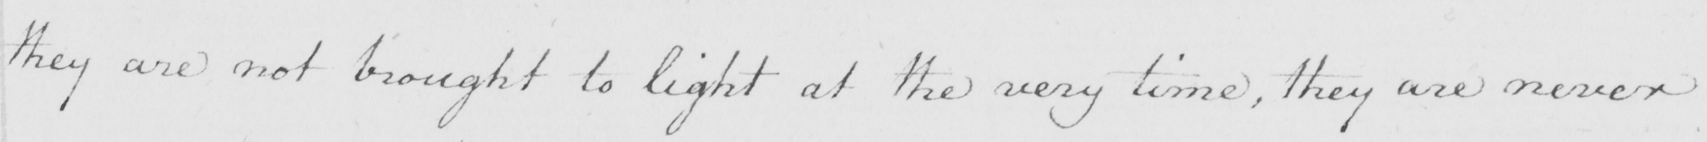Please transcribe the handwritten text in this image. they are not brought to light at the very time , they are never 